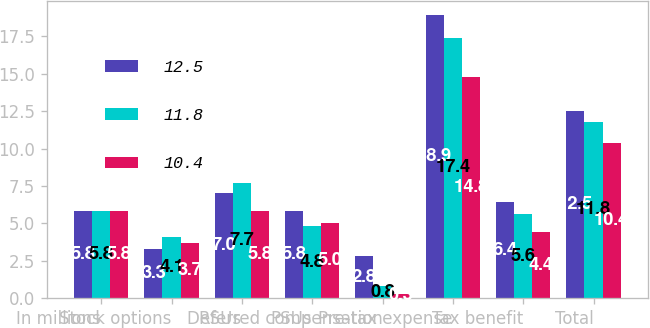<chart> <loc_0><loc_0><loc_500><loc_500><stacked_bar_chart><ecel><fcel>In millions<fcel>Stock options<fcel>RSUs<fcel>PSUs<fcel>Deferred compensation<fcel>Pre-tax expense<fcel>Tax benefit<fcel>Total<nl><fcel>12.5<fcel>5.8<fcel>3.3<fcel>7<fcel>5.8<fcel>2.8<fcel>18.9<fcel>6.4<fcel>12.5<nl><fcel>11.8<fcel>5.8<fcel>4.1<fcel>7.7<fcel>4.8<fcel>0.8<fcel>17.4<fcel>5.6<fcel>11.8<nl><fcel>10.4<fcel>5.8<fcel>3.7<fcel>5.8<fcel>5<fcel>0.3<fcel>14.8<fcel>4.4<fcel>10.4<nl></chart> 